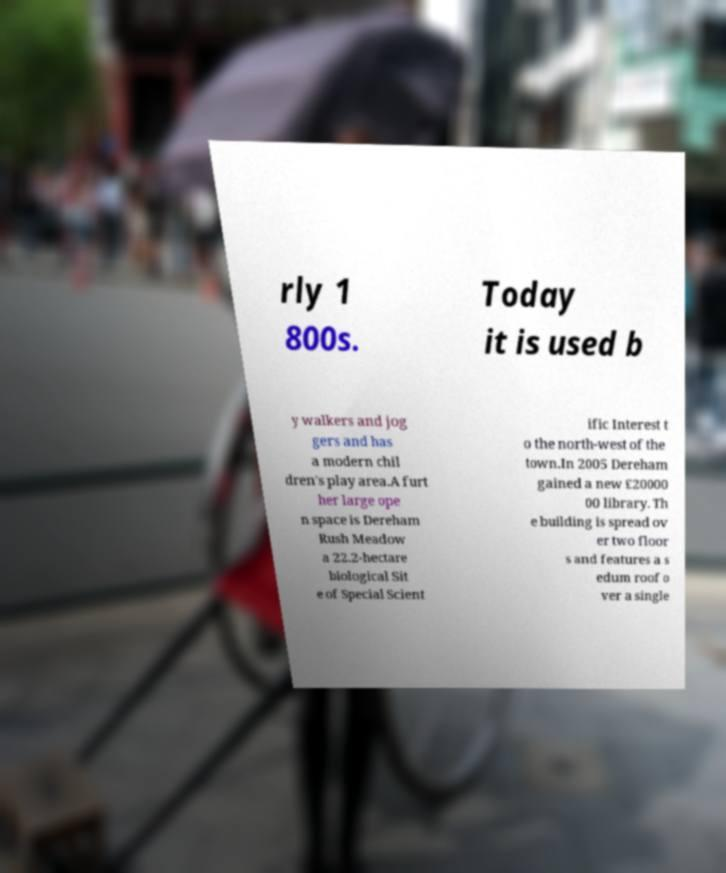What messages or text are displayed in this image? I need them in a readable, typed format. rly 1 800s. Today it is used b y walkers and jog gers and has a modern chil dren's play area.A furt her large ope n space is Dereham Rush Meadow a 22.2-hectare biological Sit e of Special Scient ific Interest t o the north-west of the town.In 2005 Dereham gained a new £20000 00 library. Th e building is spread ov er two floor s and features a s edum roof o ver a single 